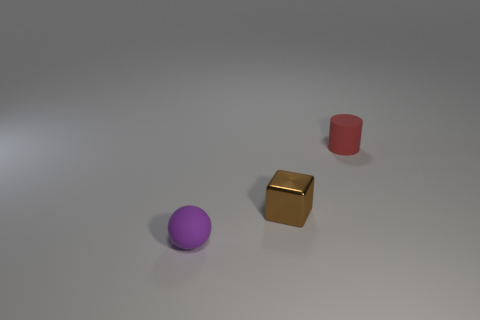Add 2 small purple blocks. How many objects exist? 5 Subtract all cylinders. How many objects are left? 2 Add 2 small cylinders. How many small cylinders are left? 3 Add 1 red matte objects. How many red matte objects exist? 2 Subtract 0 blue spheres. How many objects are left? 3 Subtract 1 blocks. How many blocks are left? 0 Subtract all purple cylinders. Subtract all cyan cubes. How many cylinders are left? 1 Subtract all small shiny things. Subtract all tiny purple rubber objects. How many objects are left? 1 